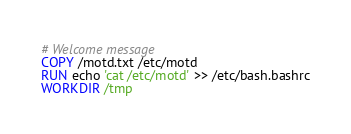Convert code to text. <code><loc_0><loc_0><loc_500><loc_500><_Dockerfile_># Welcome message
COPY /motd.txt /etc/motd
RUN echo 'cat /etc/motd' >> /etc/bash.bashrc
WORKDIR /tmp
</code> 